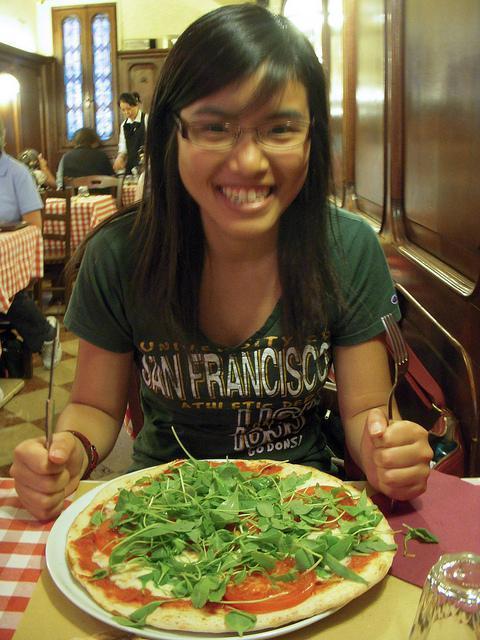How many people can be seen?
Give a very brief answer. 4. How many dining tables are there?
Give a very brief answer. 3. How many handbags can you see?
Give a very brief answer. 1. 